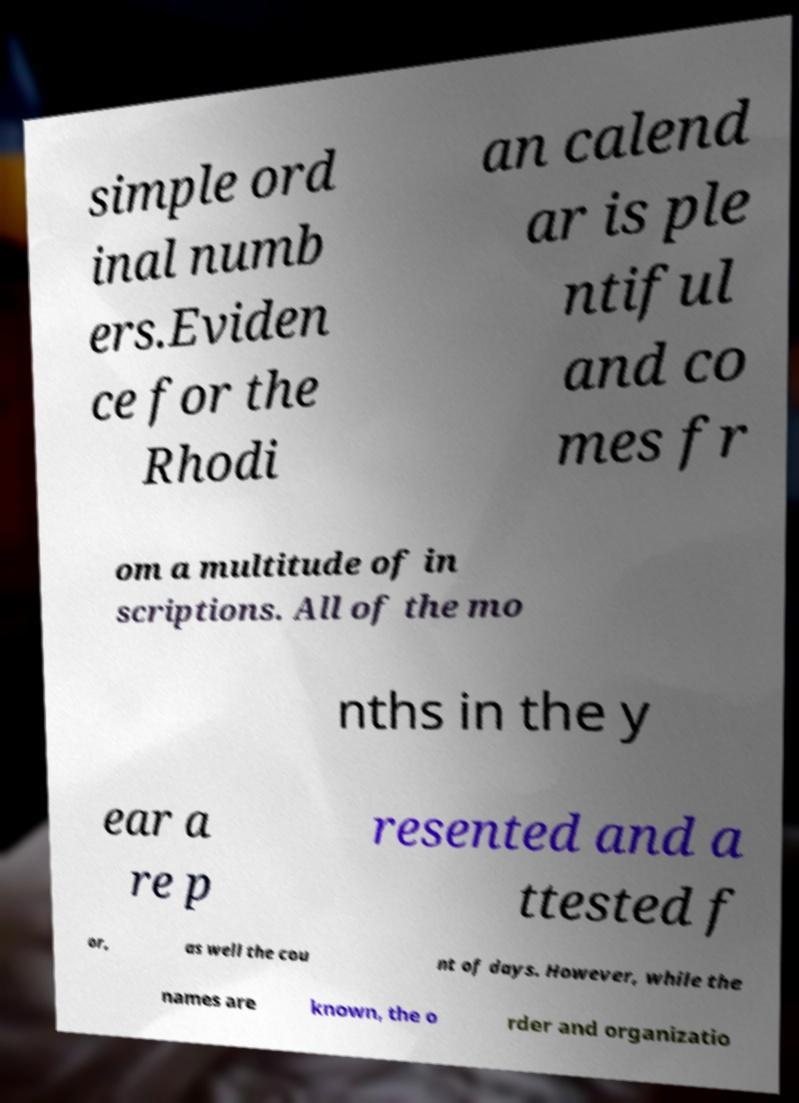For documentation purposes, I need the text within this image transcribed. Could you provide that? simple ord inal numb ers.Eviden ce for the Rhodi an calend ar is ple ntiful and co mes fr om a multitude of in scriptions. All of the mo nths in the y ear a re p resented and a ttested f or, as well the cou nt of days. However, while the names are known, the o rder and organizatio 